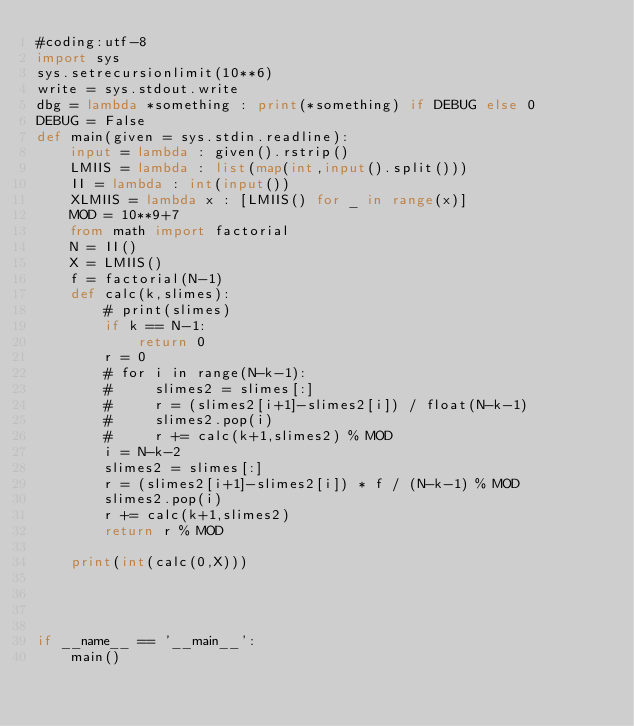Convert code to text. <code><loc_0><loc_0><loc_500><loc_500><_Python_>#coding:utf-8
import sys
sys.setrecursionlimit(10**6)
write = sys.stdout.write
dbg = lambda *something : print(*something) if DEBUG else 0
DEBUG = False
def main(given = sys.stdin.readline):
    input = lambda : given().rstrip()
    LMIIS = lambda : list(map(int,input().split()))
    II = lambda : int(input())
    XLMIIS = lambda x : [LMIIS() for _ in range(x)]
    MOD = 10**9+7
    from math import factorial
    N = II()
    X = LMIIS()
    f = factorial(N-1)
    def calc(k,slimes):
        # print(slimes)
        if k == N-1:
            return 0
        r = 0
        # for i in range(N-k-1):
        #     slimes2 = slimes[:]
        #     r = (slimes2[i+1]-slimes2[i]) / float(N-k-1)
        #     slimes2.pop(i)
        #     r += calc(k+1,slimes2) % MOD
        i = N-k-2
        slimes2 = slimes[:]
        r = (slimes2[i+1]-slimes2[i]) * f / (N-k-1) % MOD
        slimes2.pop(i)
        r += calc(k+1,slimes2) 
        return r % MOD
    
    print(int(calc(0,X)))




if __name__ == '__main__':
    main()</code> 